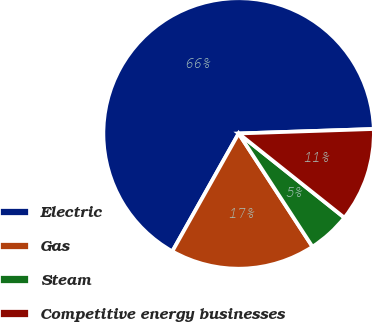<chart> <loc_0><loc_0><loc_500><loc_500><pie_chart><fcel>Electric<fcel>Gas<fcel>Steam<fcel>Competitive energy businesses<nl><fcel>66.32%<fcel>17.35%<fcel>5.1%<fcel>11.23%<nl></chart> 